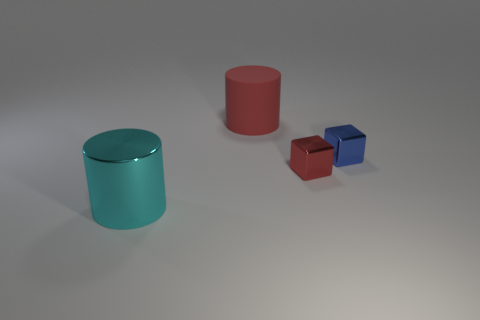There is a cyan object that is the same material as the tiny blue block; what is its size? The cyan object is significantly larger than the tiny blue block. Despite sharing the same glossy material finish, the cyan object appears to be a considerably larger cylinder, suggesting it might stand as a prominent item in the given context. 